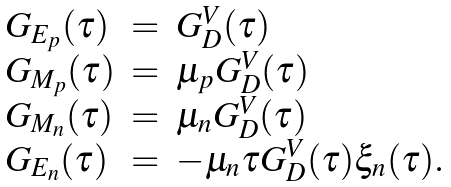<formula> <loc_0><loc_0><loc_500><loc_500>\begin{array} { l c l } G _ { E _ { p } } ( \tau ) & = & G _ { D } ^ { V } ( \tau ) \\ G _ { M _ { p } } ( \tau ) & = & \mu _ { p } G _ { D } ^ { V } ( \tau ) \\ G _ { M _ { n } } ( \tau ) & = & \mu _ { n } G _ { D } ^ { V } ( \tau ) \\ G _ { E _ { n } } ( \tau ) & = & - \mu _ { n } \tau G _ { D } ^ { V } ( \tau ) \xi _ { n } ( \tau ) . \end{array}</formula> 